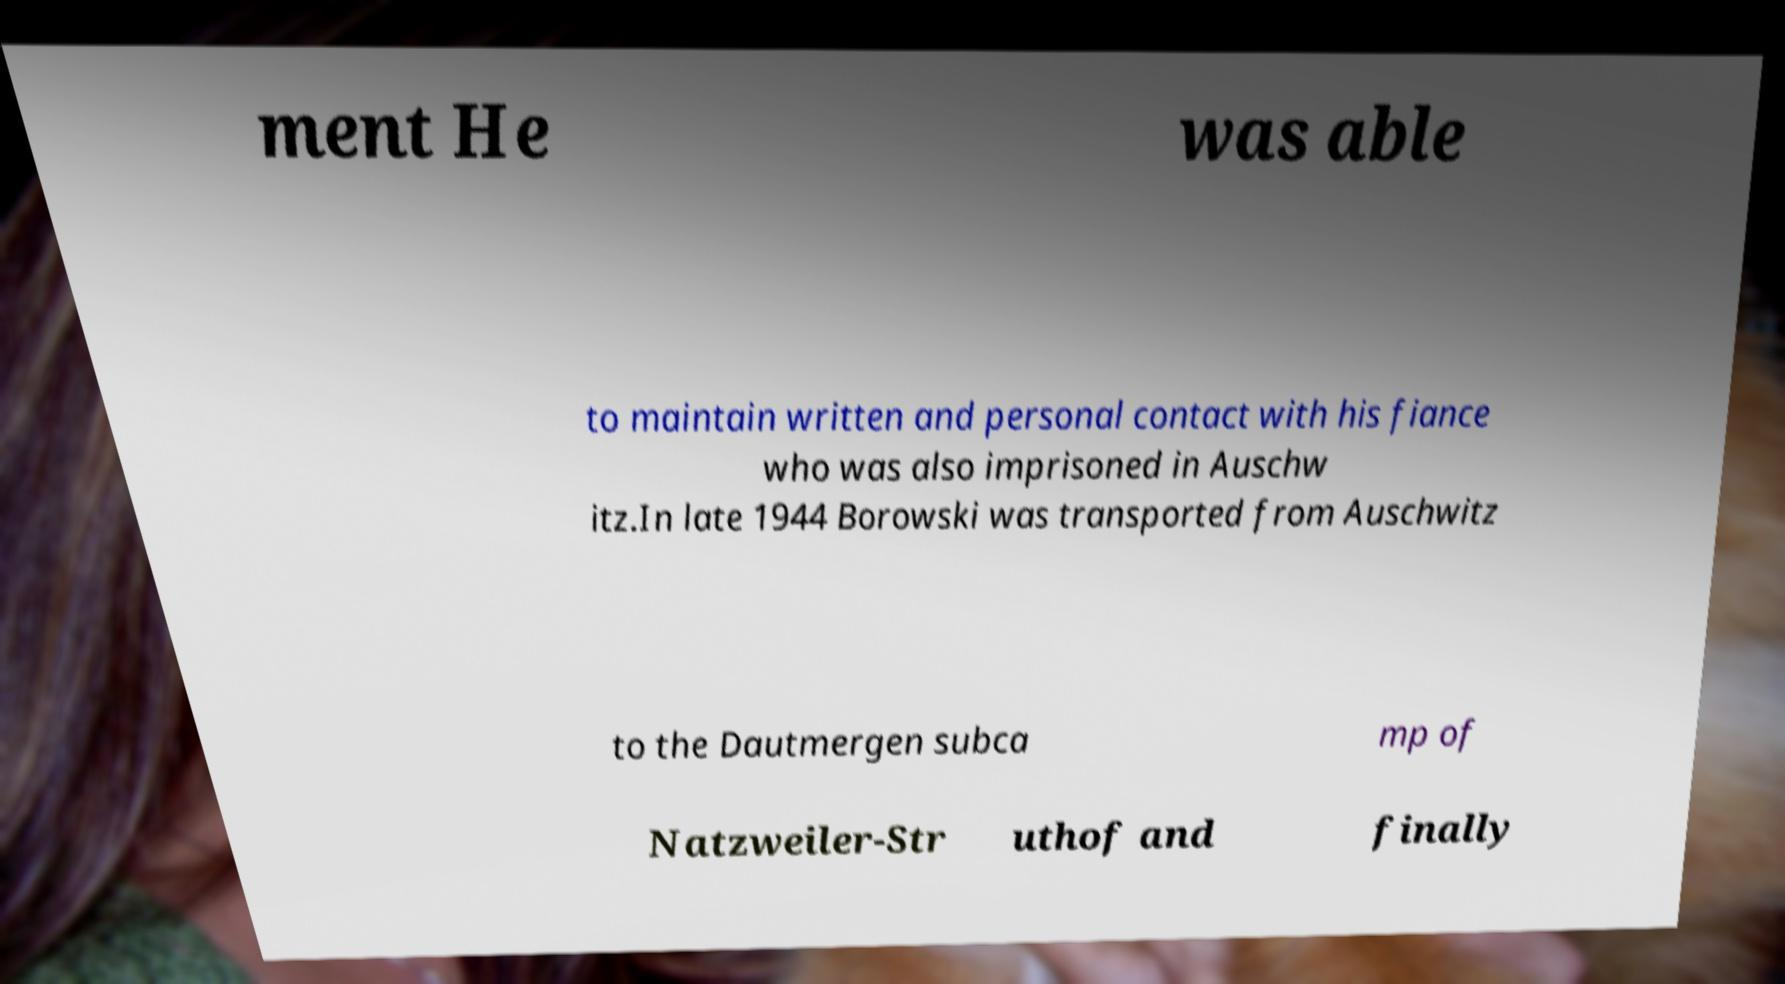Can you accurately transcribe the text from the provided image for me? ment He was able to maintain written and personal contact with his fiance who was also imprisoned in Auschw itz.In late 1944 Borowski was transported from Auschwitz to the Dautmergen subca mp of Natzweiler-Str uthof and finally 